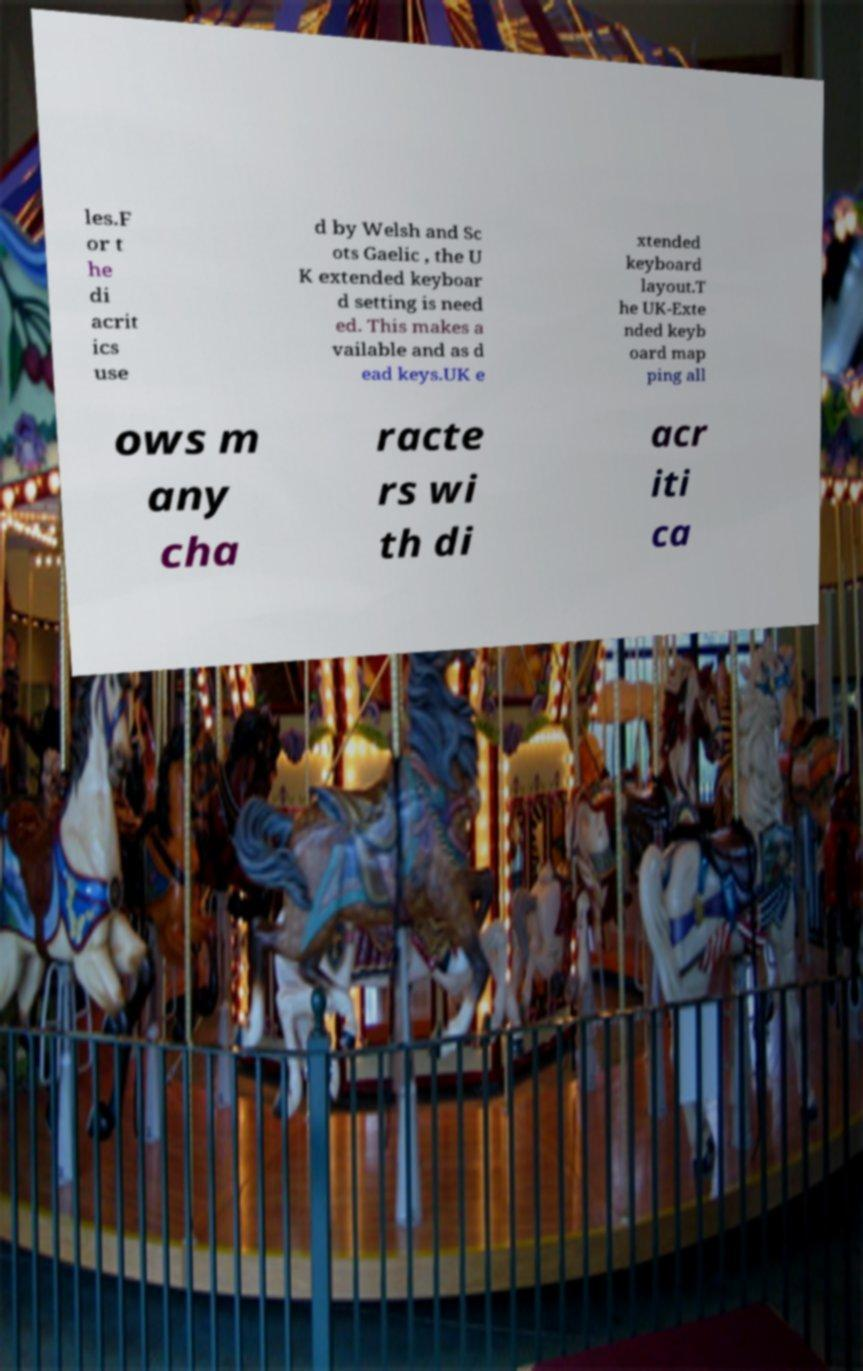I need the written content from this picture converted into text. Can you do that? les.F or t he di acrit ics use d by Welsh and Sc ots Gaelic , the U K extended keyboar d setting is need ed. This makes a vailable and as d ead keys.UK e xtended keyboard layout.T he UK-Exte nded keyb oard map ping all ows m any cha racte rs wi th di acr iti ca 